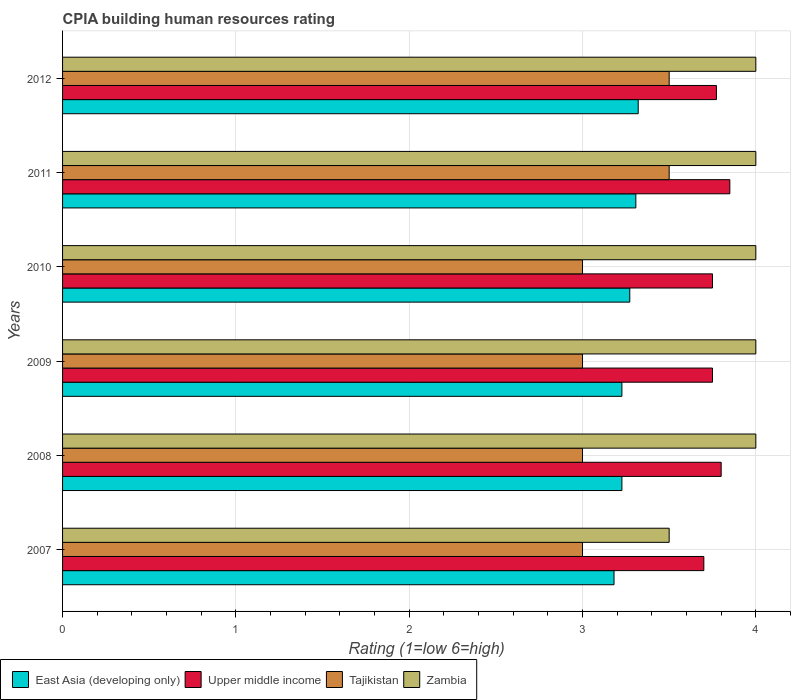How many different coloured bars are there?
Provide a short and direct response. 4. How many groups of bars are there?
Provide a succinct answer. 6. What is the label of the 6th group of bars from the top?
Keep it short and to the point. 2007. In how many cases, is the number of bars for a given year not equal to the number of legend labels?
Provide a succinct answer. 0. Across all years, what is the maximum CPIA rating in East Asia (developing only)?
Provide a short and direct response. 3.32. Across all years, what is the minimum CPIA rating in Zambia?
Ensure brevity in your answer.  3.5. In which year was the CPIA rating in East Asia (developing only) maximum?
Make the answer very short. 2012. In which year was the CPIA rating in Zambia minimum?
Offer a very short reply. 2007. What is the difference between the CPIA rating in Zambia in 2009 and the CPIA rating in Upper middle income in 2011?
Your answer should be very brief. 0.15. What is the average CPIA rating in Upper middle income per year?
Provide a short and direct response. 3.77. In the year 2007, what is the difference between the CPIA rating in East Asia (developing only) and CPIA rating in Tajikistan?
Your response must be concise. 0.18. In how many years, is the CPIA rating in Upper middle income greater than 1.4 ?
Provide a succinct answer. 6. What is the ratio of the CPIA rating in Zambia in 2007 to that in 2012?
Make the answer very short. 0.88. Is the CPIA rating in East Asia (developing only) in 2008 less than that in 2009?
Keep it short and to the point. No. Is the difference between the CPIA rating in East Asia (developing only) in 2007 and 2011 greater than the difference between the CPIA rating in Tajikistan in 2007 and 2011?
Provide a succinct answer. Yes. What is the difference between the highest and the second highest CPIA rating in Upper middle income?
Provide a succinct answer. 0.05. What is the difference between the highest and the lowest CPIA rating in Zambia?
Keep it short and to the point. 0.5. In how many years, is the CPIA rating in Tajikistan greater than the average CPIA rating in Tajikistan taken over all years?
Make the answer very short. 2. What does the 2nd bar from the top in 2009 represents?
Keep it short and to the point. Tajikistan. What does the 3rd bar from the bottom in 2009 represents?
Keep it short and to the point. Tajikistan. Is it the case that in every year, the sum of the CPIA rating in East Asia (developing only) and CPIA rating in Upper middle income is greater than the CPIA rating in Zambia?
Your answer should be compact. Yes. Where does the legend appear in the graph?
Your answer should be very brief. Bottom left. How are the legend labels stacked?
Your answer should be compact. Horizontal. What is the title of the graph?
Offer a very short reply. CPIA building human resources rating. What is the label or title of the X-axis?
Offer a very short reply. Rating (1=low 6=high). What is the Rating (1=low 6=high) of East Asia (developing only) in 2007?
Keep it short and to the point. 3.18. What is the Rating (1=low 6=high) in Upper middle income in 2007?
Provide a short and direct response. 3.7. What is the Rating (1=low 6=high) of Tajikistan in 2007?
Ensure brevity in your answer.  3. What is the Rating (1=low 6=high) in Zambia in 2007?
Give a very brief answer. 3.5. What is the Rating (1=low 6=high) in East Asia (developing only) in 2008?
Your answer should be compact. 3.23. What is the Rating (1=low 6=high) in East Asia (developing only) in 2009?
Make the answer very short. 3.23. What is the Rating (1=low 6=high) in Upper middle income in 2009?
Ensure brevity in your answer.  3.75. What is the Rating (1=low 6=high) of East Asia (developing only) in 2010?
Provide a short and direct response. 3.27. What is the Rating (1=low 6=high) of Upper middle income in 2010?
Your answer should be very brief. 3.75. What is the Rating (1=low 6=high) of Tajikistan in 2010?
Provide a short and direct response. 3. What is the Rating (1=low 6=high) of East Asia (developing only) in 2011?
Give a very brief answer. 3.31. What is the Rating (1=low 6=high) of Upper middle income in 2011?
Provide a succinct answer. 3.85. What is the Rating (1=low 6=high) in Tajikistan in 2011?
Provide a short and direct response. 3.5. What is the Rating (1=low 6=high) in East Asia (developing only) in 2012?
Provide a succinct answer. 3.32. What is the Rating (1=low 6=high) in Upper middle income in 2012?
Keep it short and to the point. 3.77. What is the Rating (1=low 6=high) in Tajikistan in 2012?
Your response must be concise. 3.5. Across all years, what is the maximum Rating (1=low 6=high) in East Asia (developing only)?
Keep it short and to the point. 3.32. Across all years, what is the maximum Rating (1=low 6=high) in Upper middle income?
Your answer should be compact. 3.85. Across all years, what is the minimum Rating (1=low 6=high) of East Asia (developing only)?
Your answer should be very brief. 3.18. Across all years, what is the minimum Rating (1=low 6=high) of Upper middle income?
Make the answer very short. 3.7. Across all years, what is the minimum Rating (1=low 6=high) in Tajikistan?
Offer a very short reply. 3. Across all years, what is the minimum Rating (1=low 6=high) in Zambia?
Ensure brevity in your answer.  3.5. What is the total Rating (1=low 6=high) of East Asia (developing only) in the graph?
Make the answer very short. 19.54. What is the total Rating (1=low 6=high) of Upper middle income in the graph?
Provide a succinct answer. 22.62. What is the total Rating (1=low 6=high) of Zambia in the graph?
Keep it short and to the point. 23.5. What is the difference between the Rating (1=low 6=high) in East Asia (developing only) in 2007 and that in 2008?
Ensure brevity in your answer.  -0.05. What is the difference between the Rating (1=low 6=high) in Upper middle income in 2007 and that in 2008?
Make the answer very short. -0.1. What is the difference between the Rating (1=low 6=high) of Zambia in 2007 and that in 2008?
Give a very brief answer. -0.5. What is the difference between the Rating (1=low 6=high) of East Asia (developing only) in 2007 and that in 2009?
Offer a terse response. -0.05. What is the difference between the Rating (1=low 6=high) in Tajikistan in 2007 and that in 2009?
Ensure brevity in your answer.  0. What is the difference between the Rating (1=low 6=high) of East Asia (developing only) in 2007 and that in 2010?
Keep it short and to the point. -0.09. What is the difference between the Rating (1=low 6=high) in Tajikistan in 2007 and that in 2010?
Ensure brevity in your answer.  0. What is the difference between the Rating (1=low 6=high) in East Asia (developing only) in 2007 and that in 2011?
Your response must be concise. -0.13. What is the difference between the Rating (1=low 6=high) in Tajikistan in 2007 and that in 2011?
Provide a succinct answer. -0.5. What is the difference between the Rating (1=low 6=high) of East Asia (developing only) in 2007 and that in 2012?
Make the answer very short. -0.14. What is the difference between the Rating (1=low 6=high) of Upper middle income in 2007 and that in 2012?
Provide a succinct answer. -0.07. What is the difference between the Rating (1=low 6=high) in East Asia (developing only) in 2008 and that in 2009?
Provide a succinct answer. 0. What is the difference between the Rating (1=low 6=high) in Tajikistan in 2008 and that in 2009?
Your answer should be very brief. 0. What is the difference between the Rating (1=low 6=high) in Zambia in 2008 and that in 2009?
Provide a short and direct response. 0. What is the difference between the Rating (1=low 6=high) of East Asia (developing only) in 2008 and that in 2010?
Your answer should be very brief. -0.05. What is the difference between the Rating (1=low 6=high) in Tajikistan in 2008 and that in 2010?
Your answer should be compact. 0. What is the difference between the Rating (1=low 6=high) in Zambia in 2008 and that in 2010?
Make the answer very short. 0. What is the difference between the Rating (1=low 6=high) of East Asia (developing only) in 2008 and that in 2011?
Your answer should be very brief. -0.08. What is the difference between the Rating (1=low 6=high) of Upper middle income in 2008 and that in 2011?
Offer a very short reply. -0.05. What is the difference between the Rating (1=low 6=high) of Zambia in 2008 and that in 2011?
Your answer should be compact. 0. What is the difference between the Rating (1=low 6=high) of East Asia (developing only) in 2008 and that in 2012?
Offer a very short reply. -0.09. What is the difference between the Rating (1=low 6=high) of Upper middle income in 2008 and that in 2012?
Provide a short and direct response. 0.03. What is the difference between the Rating (1=low 6=high) of Tajikistan in 2008 and that in 2012?
Provide a succinct answer. -0.5. What is the difference between the Rating (1=low 6=high) of East Asia (developing only) in 2009 and that in 2010?
Your answer should be very brief. -0.05. What is the difference between the Rating (1=low 6=high) in Upper middle income in 2009 and that in 2010?
Provide a succinct answer. 0. What is the difference between the Rating (1=low 6=high) in Tajikistan in 2009 and that in 2010?
Your answer should be very brief. 0. What is the difference between the Rating (1=low 6=high) of Zambia in 2009 and that in 2010?
Provide a succinct answer. 0. What is the difference between the Rating (1=low 6=high) of East Asia (developing only) in 2009 and that in 2011?
Your response must be concise. -0.08. What is the difference between the Rating (1=low 6=high) in Zambia in 2009 and that in 2011?
Ensure brevity in your answer.  0. What is the difference between the Rating (1=low 6=high) of East Asia (developing only) in 2009 and that in 2012?
Offer a terse response. -0.09. What is the difference between the Rating (1=low 6=high) of Upper middle income in 2009 and that in 2012?
Offer a terse response. -0.02. What is the difference between the Rating (1=low 6=high) of Zambia in 2009 and that in 2012?
Your answer should be very brief. 0. What is the difference between the Rating (1=low 6=high) in East Asia (developing only) in 2010 and that in 2011?
Ensure brevity in your answer.  -0.04. What is the difference between the Rating (1=low 6=high) in Upper middle income in 2010 and that in 2011?
Provide a succinct answer. -0.1. What is the difference between the Rating (1=low 6=high) in Tajikistan in 2010 and that in 2011?
Provide a succinct answer. -0.5. What is the difference between the Rating (1=low 6=high) of East Asia (developing only) in 2010 and that in 2012?
Your answer should be very brief. -0.05. What is the difference between the Rating (1=low 6=high) of Upper middle income in 2010 and that in 2012?
Provide a short and direct response. -0.02. What is the difference between the Rating (1=low 6=high) in East Asia (developing only) in 2011 and that in 2012?
Make the answer very short. -0.01. What is the difference between the Rating (1=low 6=high) in Upper middle income in 2011 and that in 2012?
Your answer should be very brief. 0.08. What is the difference between the Rating (1=low 6=high) of Zambia in 2011 and that in 2012?
Ensure brevity in your answer.  0. What is the difference between the Rating (1=low 6=high) in East Asia (developing only) in 2007 and the Rating (1=low 6=high) in Upper middle income in 2008?
Offer a very short reply. -0.62. What is the difference between the Rating (1=low 6=high) in East Asia (developing only) in 2007 and the Rating (1=low 6=high) in Tajikistan in 2008?
Your answer should be very brief. 0.18. What is the difference between the Rating (1=low 6=high) in East Asia (developing only) in 2007 and the Rating (1=low 6=high) in Zambia in 2008?
Your answer should be very brief. -0.82. What is the difference between the Rating (1=low 6=high) in Upper middle income in 2007 and the Rating (1=low 6=high) in Zambia in 2008?
Offer a very short reply. -0.3. What is the difference between the Rating (1=low 6=high) of East Asia (developing only) in 2007 and the Rating (1=low 6=high) of Upper middle income in 2009?
Offer a very short reply. -0.57. What is the difference between the Rating (1=low 6=high) in East Asia (developing only) in 2007 and the Rating (1=low 6=high) in Tajikistan in 2009?
Your answer should be compact. 0.18. What is the difference between the Rating (1=low 6=high) in East Asia (developing only) in 2007 and the Rating (1=low 6=high) in Zambia in 2009?
Keep it short and to the point. -0.82. What is the difference between the Rating (1=low 6=high) of East Asia (developing only) in 2007 and the Rating (1=low 6=high) of Upper middle income in 2010?
Offer a very short reply. -0.57. What is the difference between the Rating (1=low 6=high) in East Asia (developing only) in 2007 and the Rating (1=low 6=high) in Tajikistan in 2010?
Offer a very short reply. 0.18. What is the difference between the Rating (1=low 6=high) in East Asia (developing only) in 2007 and the Rating (1=low 6=high) in Zambia in 2010?
Your answer should be very brief. -0.82. What is the difference between the Rating (1=low 6=high) of Upper middle income in 2007 and the Rating (1=low 6=high) of Tajikistan in 2010?
Give a very brief answer. 0.7. What is the difference between the Rating (1=low 6=high) of Upper middle income in 2007 and the Rating (1=low 6=high) of Zambia in 2010?
Your answer should be very brief. -0.3. What is the difference between the Rating (1=low 6=high) in Tajikistan in 2007 and the Rating (1=low 6=high) in Zambia in 2010?
Your response must be concise. -1. What is the difference between the Rating (1=low 6=high) in East Asia (developing only) in 2007 and the Rating (1=low 6=high) in Upper middle income in 2011?
Give a very brief answer. -0.67. What is the difference between the Rating (1=low 6=high) of East Asia (developing only) in 2007 and the Rating (1=low 6=high) of Tajikistan in 2011?
Your response must be concise. -0.32. What is the difference between the Rating (1=low 6=high) of East Asia (developing only) in 2007 and the Rating (1=low 6=high) of Zambia in 2011?
Keep it short and to the point. -0.82. What is the difference between the Rating (1=low 6=high) in Upper middle income in 2007 and the Rating (1=low 6=high) in Tajikistan in 2011?
Offer a terse response. 0.2. What is the difference between the Rating (1=low 6=high) of Tajikistan in 2007 and the Rating (1=low 6=high) of Zambia in 2011?
Your response must be concise. -1. What is the difference between the Rating (1=low 6=high) of East Asia (developing only) in 2007 and the Rating (1=low 6=high) of Upper middle income in 2012?
Your answer should be very brief. -0.59. What is the difference between the Rating (1=low 6=high) in East Asia (developing only) in 2007 and the Rating (1=low 6=high) in Tajikistan in 2012?
Your answer should be very brief. -0.32. What is the difference between the Rating (1=low 6=high) in East Asia (developing only) in 2007 and the Rating (1=low 6=high) in Zambia in 2012?
Ensure brevity in your answer.  -0.82. What is the difference between the Rating (1=low 6=high) in Upper middle income in 2007 and the Rating (1=low 6=high) in Tajikistan in 2012?
Your answer should be compact. 0.2. What is the difference between the Rating (1=low 6=high) in Upper middle income in 2007 and the Rating (1=low 6=high) in Zambia in 2012?
Give a very brief answer. -0.3. What is the difference between the Rating (1=low 6=high) of East Asia (developing only) in 2008 and the Rating (1=low 6=high) of Upper middle income in 2009?
Your answer should be very brief. -0.52. What is the difference between the Rating (1=low 6=high) in East Asia (developing only) in 2008 and the Rating (1=low 6=high) in Tajikistan in 2009?
Give a very brief answer. 0.23. What is the difference between the Rating (1=low 6=high) of East Asia (developing only) in 2008 and the Rating (1=low 6=high) of Zambia in 2009?
Give a very brief answer. -0.77. What is the difference between the Rating (1=low 6=high) of Upper middle income in 2008 and the Rating (1=low 6=high) of Zambia in 2009?
Make the answer very short. -0.2. What is the difference between the Rating (1=low 6=high) of East Asia (developing only) in 2008 and the Rating (1=low 6=high) of Upper middle income in 2010?
Make the answer very short. -0.52. What is the difference between the Rating (1=low 6=high) of East Asia (developing only) in 2008 and the Rating (1=low 6=high) of Tajikistan in 2010?
Offer a terse response. 0.23. What is the difference between the Rating (1=low 6=high) of East Asia (developing only) in 2008 and the Rating (1=low 6=high) of Zambia in 2010?
Offer a very short reply. -0.77. What is the difference between the Rating (1=low 6=high) of East Asia (developing only) in 2008 and the Rating (1=low 6=high) of Upper middle income in 2011?
Keep it short and to the point. -0.62. What is the difference between the Rating (1=low 6=high) of East Asia (developing only) in 2008 and the Rating (1=low 6=high) of Tajikistan in 2011?
Provide a short and direct response. -0.27. What is the difference between the Rating (1=low 6=high) in East Asia (developing only) in 2008 and the Rating (1=low 6=high) in Zambia in 2011?
Offer a terse response. -0.77. What is the difference between the Rating (1=low 6=high) in Upper middle income in 2008 and the Rating (1=low 6=high) in Zambia in 2011?
Your response must be concise. -0.2. What is the difference between the Rating (1=low 6=high) in East Asia (developing only) in 2008 and the Rating (1=low 6=high) in Upper middle income in 2012?
Your answer should be compact. -0.55. What is the difference between the Rating (1=low 6=high) in East Asia (developing only) in 2008 and the Rating (1=low 6=high) in Tajikistan in 2012?
Make the answer very short. -0.27. What is the difference between the Rating (1=low 6=high) of East Asia (developing only) in 2008 and the Rating (1=low 6=high) of Zambia in 2012?
Offer a very short reply. -0.77. What is the difference between the Rating (1=low 6=high) of Upper middle income in 2008 and the Rating (1=low 6=high) of Tajikistan in 2012?
Ensure brevity in your answer.  0.3. What is the difference between the Rating (1=low 6=high) of Tajikistan in 2008 and the Rating (1=low 6=high) of Zambia in 2012?
Offer a terse response. -1. What is the difference between the Rating (1=low 6=high) in East Asia (developing only) in 2009 and the Rating (1=low 6=high) in Upper middle income in 2010?
Ensure brevity in your answer.  -0.52. What is the difference between the Rating (1=low 6=high) in East Asia (developing only) in 2009 and the Rating (1=low 6=high) in Tajikistan in 2010?
Offer a terse response. 0.23. What is the difference between the Rating (1=low 6=high) in East Asia (developing only) in 2009 and the Rating (1=low 6=high) in Zambia in 2010?
Provide a succinct answer. -0.77. What is the difference between the Rating (1=low 6=high) in Upper middle income in 2009 and the Rating (1=low 6=high) in Tajikistan in 2010?
Your response must be concise. 0.75. What is the difference between the Rating (1=low 6=high) in Upper middle income in 2009 and the Rating (1=low 6=high) in Zambia in 2010?
Keep it short and to the point. -0.25. What is the difference between the Rating (1=low 6=high) in Tajikistan in 2009 and the Rating (1=low 6=high) in Zambia in 2010?
Ensure brevity in your answer.  -1. What is the difference between the Rating (1=low 6=high) of East Asia (developing only) in 2009 and the Rating (1=low 6=high) of Upper middle income in 2011?
Make the answer very short. -0.62. What is the difference between the Rating (1=low 6=high) in East Asia (developing only) in 2009 and the Rating (1=low 6=high) in Tajikistan in 2011?
Provide a short and direct response. -0.27. What is the difference between the Rating (1=low 6=high) in East Asia (developing only) in 2009 and the Rating (1=low 6=high) in Zambia in 2011?
Your answer should be compact. -0.77. What is the difference between the Rating (1=low 6=high) of Upper middle income in 2009 and the Rating (1=low 6=high) of Tajikistan in 2011?
Your response must be concise. 0.25. What is the difference between the Rating (1=low 6=high) of East Asia (developing only) in 2009 and the Rating (1=low 6=high) of Upper middle income in 2012?
Provide a succinct answer. -0.55. What is the difference between the Rating (1=low 6=high) in East Asia (developing only) in 2009 and the Rating (1=low 6=high) in Tajikistan in 2012?
Your response must be concise. -0.27. What is the difference between the Rating (1=low 6=high) of East Asia (developing only) in 2009 and the Rating (1=low 6=high) of Zambia in 2012?
Your answer should be very brief. -0.77. What is the difference between the Rating (1=low 6=high) of Upper middle income in 2009 and the Rating (1=low 6=high) of Tajikistan in 2012?
Keep it short and to the point. 0.25. What is the difference between the Rating (1=low 6=high) of Tajikistan in 2009 and the Rating (1=low 6=high) of Zambia in 2012?
Keep it short and to the point. -1. What is the difference between the Rating (1=low 6=high) of East Asia (developing only) in 2010 and the Rating (1=low 6=high) of Upper middle income in 2011?
Make the answer very short. -0.58. What is the difference between the Rating (1=low 6=high) in East Asia (developing only) in 2010 and the Rating (1=low 6=high) in Tajikistan in 2011?
Keep it short and to the point. -0.23. What is the difference between the Rating (1=low 6=high) of East Asia (developing only) in 2010 and the Rating (1=low 6=high) of Zambia in 2011?
Provide a succinct answer. -0.73. What is the difference between the Rating (1=low 6=high) of Upper middle income in 2010 and the Rating (1=low 6=high) of Zambia in 2011?
Offer a terse response. -0.25. What is the difference between the Rating (1=low 6=high) of East Asia (developing only) in 2010 and the Rating (1=low 6=high) of Tajikistan in 2012?
Give a very brief answer. -0.23. What is the difference between the Rating (1=low 6=high) of East Asia (developing only) in 2010 and the Rating (1=low 6=high) of Zambia in 2012?
Ensure brevity in your answer.  -0.73. What is the difference between the Rating (1=low 6=high) in Tajikistan in 2010 and the Rating (1=low 6=high) in Zambia in 2012?
Keep it short and to the point. -1. What is the difference between the Rating (1=low 6=high) of East Asia (developing only) in 2011 and the Rating (1=low 6=high) of Upper middle income in 2012?
Your response must be concise. -0.47. What is the difference between the Rating (1=low 6=high) in East Asia (developing only) in 2011 and the Rating (1=low 6=high) in Tajikistan in 2012?
Give a very brief answer. -0.19. What is the difference between the Rating (1=low 6=high) in East Asia (developing only) in 2011 and the Rating (1=low 6=high) in Zambia in 2012?
Your answer should be compact. -0.69. What is the difference between the Rating (1=low 6=high) of Upper middle income in 2011 and the Rating (1=low 6=high) of Tajikistan in 2012?
Make the answer very short. 0.35. What is the average Rating (1=low 6=high) in East Asia (developing only) per year?
Ensure brevity in your answer.  3.26. What is the average Rating (1=low 6=high) of Upper middle income per year?
Your answer should be compact. 3.77. What is the average Rating (1=low 6=high) in Tajikistan per year?
Provide a short and direct response. 3.17. What is the average Rating (1=low 6=high) of Zambia per year?
Offer a terse response. 3.92. In the year 2007, what is the difference between the Rating (1=low 6=high) in East Asia (developing only) and Rating (1=low 6=high) in Upper middle income?
Offer a very short reply. -0.52. In the year 2007, what is the difference between the Rating (1=low 6=high) in East Asia (developing only) and Rating (1=low 6=high) in Tajikistan?
Keep it short and to the point. 0.18. In the year 2007, what is the difference between the Rating (1=low 6=high) of East Asia (developing only) and Rating (1=low 6=high) of Zambia?
Offer a very short reply. -0.32. In the year 2007, what is the difference between the Rating (1=low 6=high) in Upper middle income and Rating (1=low 6=high) in Tajikistan?
Offer a very short reply. 0.7. In the year 2007, what is the difference between the Rating (1=low 6=high) in Upper middle income and Rating (1=low 6=high) in Zambia?
Offer a very short reply. 0.2. In the year 2008, what is the difference between the Rating (1=low 6=high) of East Asia (developing only) and Rating (1=low 6=high) of Upper middle income?
Offer a very short reply. -0.57. In the year 2008, what is the difference between the Rating (1=low 6=high) of East Asia (developing only) and Rating (1=low 6=high) of Tajikistan?
Your answer should be very brief. 0.23. In the year 2008, what is the difference between the Rating (1=low 6=high) of East Asia (developing only) and Rating (1=low 6=high) of Zambia?
Keep it short and to the point. -0.77. In the year 2008, what is the difference between the Rating (1=low 6=high) in Upper middle income and Rating (1=low 6=high) in Zambia?
Offer a terse response. -0.2. In the year 2009, what is the difference between the Rating (1=low 6=high) in East Asia (developing only) and Rating (1=low 6=high) in Upper middle income?
Offer a very short reply. -0.52. In the year 2009, what is the difference between the Rating (1=low 6=high) of East Asia (developing only) and Rating (1=low 6=high) of Tajikistan?
Your answer should be compact. 0.23. In the year 2009, what is the difference between the Rating (1=low 6=high) in East Asia (developing only) and Rating (1=low 6=high) in Zambia?
Provide a short and direct response. -0.77. In the year 2009, what is the difference between the Rating (1=low 6=high) of Upper middle income and Rating (1=low 6=high) of Tajikistan?
Keep it short and to the point. 0.75. In the year 2010, what is the difference between the Rating (1=low 6=high) of East Asia (developing only) and Rating (1=low 6=high) of Upper middle income?
Your answer should be very brief. -0.48. In the year 2010, what is the difference between the Rating (1=low 6=high) of East Asia (developing only) and Rating (1=low 6=high) of Tajikistan?
Offer a terse response. 0.27. In the year 2010, what is the difference between the Rating (1=low 6=high) of East Asia (developing only) and Rating (1=low 6=high) of Zambia?
Your response must be concise. -0.73. In the year 2010, what is the difference between the Rating (1=low 6=high) of Tajikistan and Rating (1=low 6=high) of Zambia?
Provide a succinct answer. -1. In the year 2011, what is the difference between the Rating (1=low 6=high) in East Asia (developing only) and Rating (1=low 6=high) in Upper middle income?
Your answer should be compact. -0.54. In the year 2011, what is the difference between the Rating (1=low 6=high) of East Asia (developing only) and Rating (1=low 6=high) of Tajikistan?
Provide a succinct answer. -0.19. In the year 2011, what is the difference between the Rating (1=low 6=high) in East Asia (developing only) and Rating (1=low 6=high) in Zambia?
Make the answer very short. -0.69. In the year 2011, what is the difference between the Rating (1=low 6=high) in Tajikistan and Rating (1=low 6=high) in Zambia?
Your answer should be very brief. -0.5. In the year 2012, what is the difference between the Rating (1=low 6=high) in East Asia (developing only) and Rating (1=low 6=high) in Upper middle income?
Give a very brief answer. -0.45. In the year 2012, what is the difference between the Rating (1=low 6=high) of East Asia (developing only) and Rating (1=low 6=high) of Tajikistan?
Provide a succinct answer. -0.18. In the year 2012, what is the difference between the Rating (1=low 6=high) in East Asia (developing only) and Rating (1=low 6=high) in Zambia?
Your response must be concise. -0.68. In the year 2012, what is the difference between the Rating (1=low 6=high) of Upper middle income and Rating (1=low 6=high) of Tajikistan?
Ensure brevity in your answer.  0.27. In the year 2012, what is the difference between the Rating (1=low 6=high) of Upper middle income and Rating (1=low 6=high) of Zambia?
Provide a succinct answer. -0.23. What is the ratio of the Rating (1=low 6=high) of East Asia (developing only) in 2007 to that in 2008?
Your answer should be very brief. 0.99. What is the ratio of the Rating (1=low 6=high) in Upper middle income in 2007 to that in 2008?
Keep it short and to the point. 0.97. What is the ratio of the Rating (1=low 6=high) of Tajikistan in 2007 to that in 2008?
Your response must be concise. 1. What is the ratio of the Rating (1=low 6=high) of Zambia in 2007 to that in 2008?
Provide a succinct answer. 0.88. What is the ratio of the Rating (1=low 6=high) of East Asia (developing only) in 2007 to that in 2009?
Offer a very short reply. 0.99. What is the ratio of the Rating (1=low 6=high) in Upper middle income in 2007 to that in 2009?
Make the answer very short. 0.99. What is the ratio of the Rating (1=low 6=high) of Zambia in 2007 to that in 2009?
Your answer should be very brief. 0.88. What is the ratio of the Rating (1=low 6=high) in East Asia (developing only) in 2007 to that in 2010?
Make the answer very short. 0.97. What is the ratio of the Rating (1=low 6=high) in Upper middle income in 2007 to that in 2010?
Give a very brief answer. 0.99. What is the ratio of the Rating (1=low 6=high) of Tajikistan in 2007 to that in 2010?
Offer a very short reply. 1. What is the ratio of the Rating (1=low 6=high) in East Asia (developing only) in 2007 to that in 2011?
Your response must be concise. 0.96. What is the ratio of the Rating (1=low 6=high) in Zambia in 2007 to that in 2011?
Offer a terse response. 0.88. What is the ratio of the Rating (1=low 6=high) in East Asia (developing only) in 2007 to that in 2012?
Your response must be concise. 0.96. What is the ratio of the Rating (1=low 6=high) of Upper middle income in 2007 to that in 2012?
Your answer should be very brief. 0.98. What is the ratio of the Rating (1=low 6=high) of Zambia in 2007 to that in 2012?
Make the answer very short. 0.88. What is the ratio of the Rating (1=low 6=high) of East Asia (developing only) in 2008 to that in 2009?
Your answer should be compact. 1. What is the ratio of the Rating (1=low 6=high) of Upper middle income in 2008 to that in 2009?
Offer a very short reply. 1.01. What is the ratio of the Rating (1=low 6=high) in East Asia (developing only) in 2008 to that in 2010?
Keep it short and to the point. 0.99. What is the ratio of the Rating (1=low 6=high) in Upper middle income in 2008 to that in 2010?
Your response must be concise. 1.01. What is the ratio of the Rating (1=low 6=high) of Tajikistan in 2008 to that in 2010?
Keep it short and to the point. 1. What is the ratio of the Rating (1=low 6=high) in East Asia (developing only) in 2008 to that in 2011?
Provide a short and direct response. 0.98. What is the ratio of the Rating (1=low 6=high) of Tajikistan in 2008 to that in 2011?
Your response must be concise. 0.86. What is the ratio of the Rating (1=low 6=high) of East Asia (developing only) in 2008 to that in 2012?
Keep it short and to the point. 0.97. What is the ratio of the Rating (1=low 6=high) in Upper middle income in 2008 to that in 2012?
Give a very brief answer. 1.01. What is the ratio of the Rating (1=low 6=high) of Zambia in 2008 to that in 2012?
Make the answer very short. 1. What is the ratio of the Rating (1=low 6=high) of East Asia (developing only) in 2009 to that in 2010?
Your response must be concise. 0.99. What is the ratio of the Rating (1=low 6=high) in East Asia (developing only) in 2009 to that in 2011?
Make the answer very short. 0.98. What is the ratio of the Rating (1=low 6=high) of Tajikistan in 2009 to that in 2011?
Provide a succinct answer. 0.86. What is the ratio of the Rating (1=low 6=high) in East Asia (developing only) in 2009 to that in 2012?
Your response must be concise. 0.97. What is the ratio of the Rating (1=low 6=high) in East Asia (developing only) in 2010 to that in 2011?
Make the answer very short. 0.99. What is the ratio of the Rating (1=low 6=high) of Zambia in 2010 to that in 2011?
Offer a terse response. 1. What is the ratio of the Rating (1=low 6=high) in Zambia in 2010 to that in 2012?
Provide a short and direct response. 1. What is the ratio of the Rating (1=low 6=high) of Upper middle income in 2011 to that in 2012?
Make the answer very short. 1.02. What is the ratio of the Rating (1=low 6=high) of Tajikistan in 2011 to that in 2012?
Keep it short and to the point. 1. What is the difference between the highest and the second highest Rating (1=low 6=high) in East Asia (developing only)?
Your answer should be very brief. 0.01. What is the difference between the highest and the second highest Rating (1=low 6=high) in Upper middle income?
Keep it short and to the point. 0.05. What is the difference between the highest and the second highest Rating (1=low 6=high) of Tajikistan?
Give a very brief answer. 0. What is the difference between the highest and the lowest Rating (1=low 6=high) of East Asia (developing only)?
Your response must be concise. 0.14. What is the difference between the highest and the lowest Rating (1=low 6=high) of Tajikistan?
Keep it short and to the point. 0.5. 